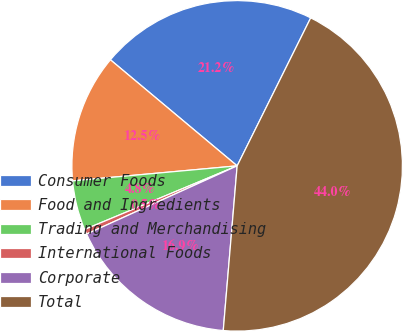Convert chart. <chart><loc_0><loc_0><loc_500><loc_500><pie_chart><fcel>Consumer Foods<fcel>Food and Ingredients<fcel>Trading and Merchandising<fcel>International Foods<fcel>Corporate<fcel>Total<nl><fcel>21.25%<fcel>12.54%<fcel>4.84%<fcel>0.48%<fcel>16.89%<fcel>44.0%<nl></chart> 